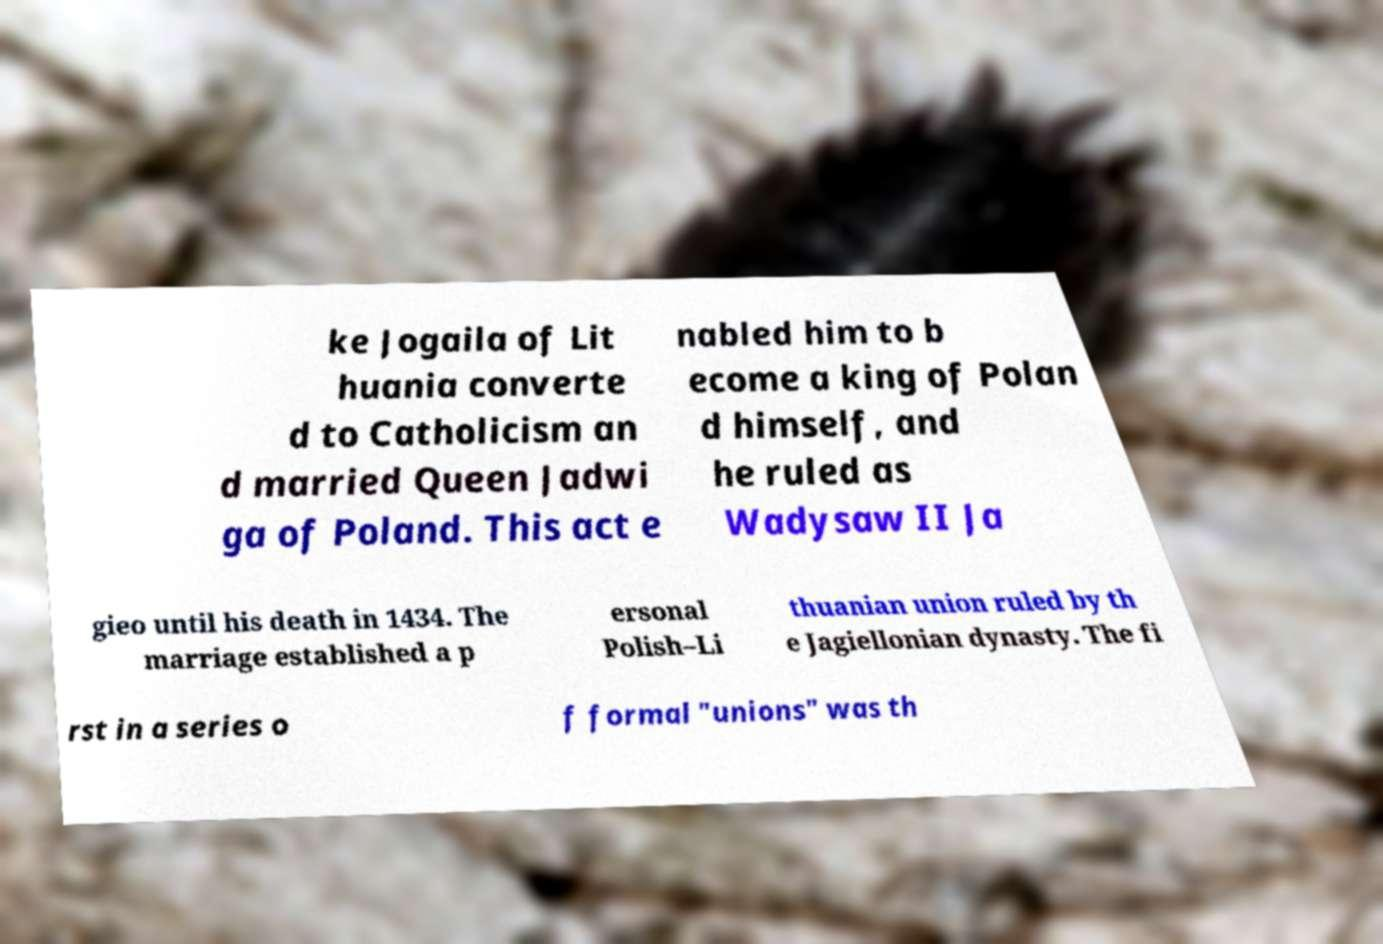For documentation purposes, I need the text within this image transcribed. Could you provide that? ke Jogaila of Lit huania converte d to Catholicism an d married Queen Jadwi ga of Poland. This act e nabled him to b ecome a king of Polan d himself, and he ruled as Wadysaw II Ja gieo until his death in 1434. The marriage established a p ersonal Polish–Li thuanian union ruled by th e Jagiellonian dynasty. The fi rst in a series o f formal "unions" was th 